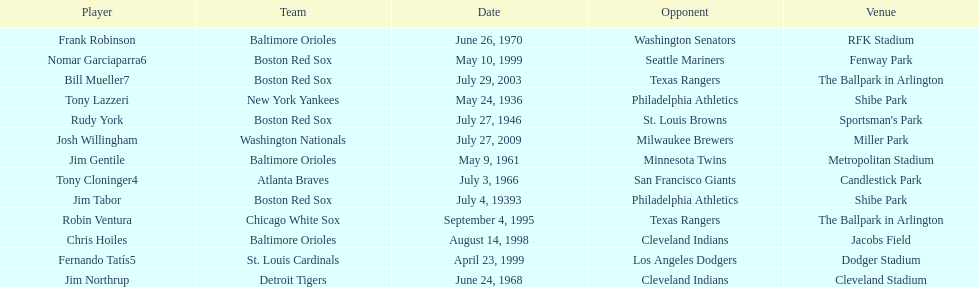What was the name of the last person to accomplish this up to date? Josh Willingham. 